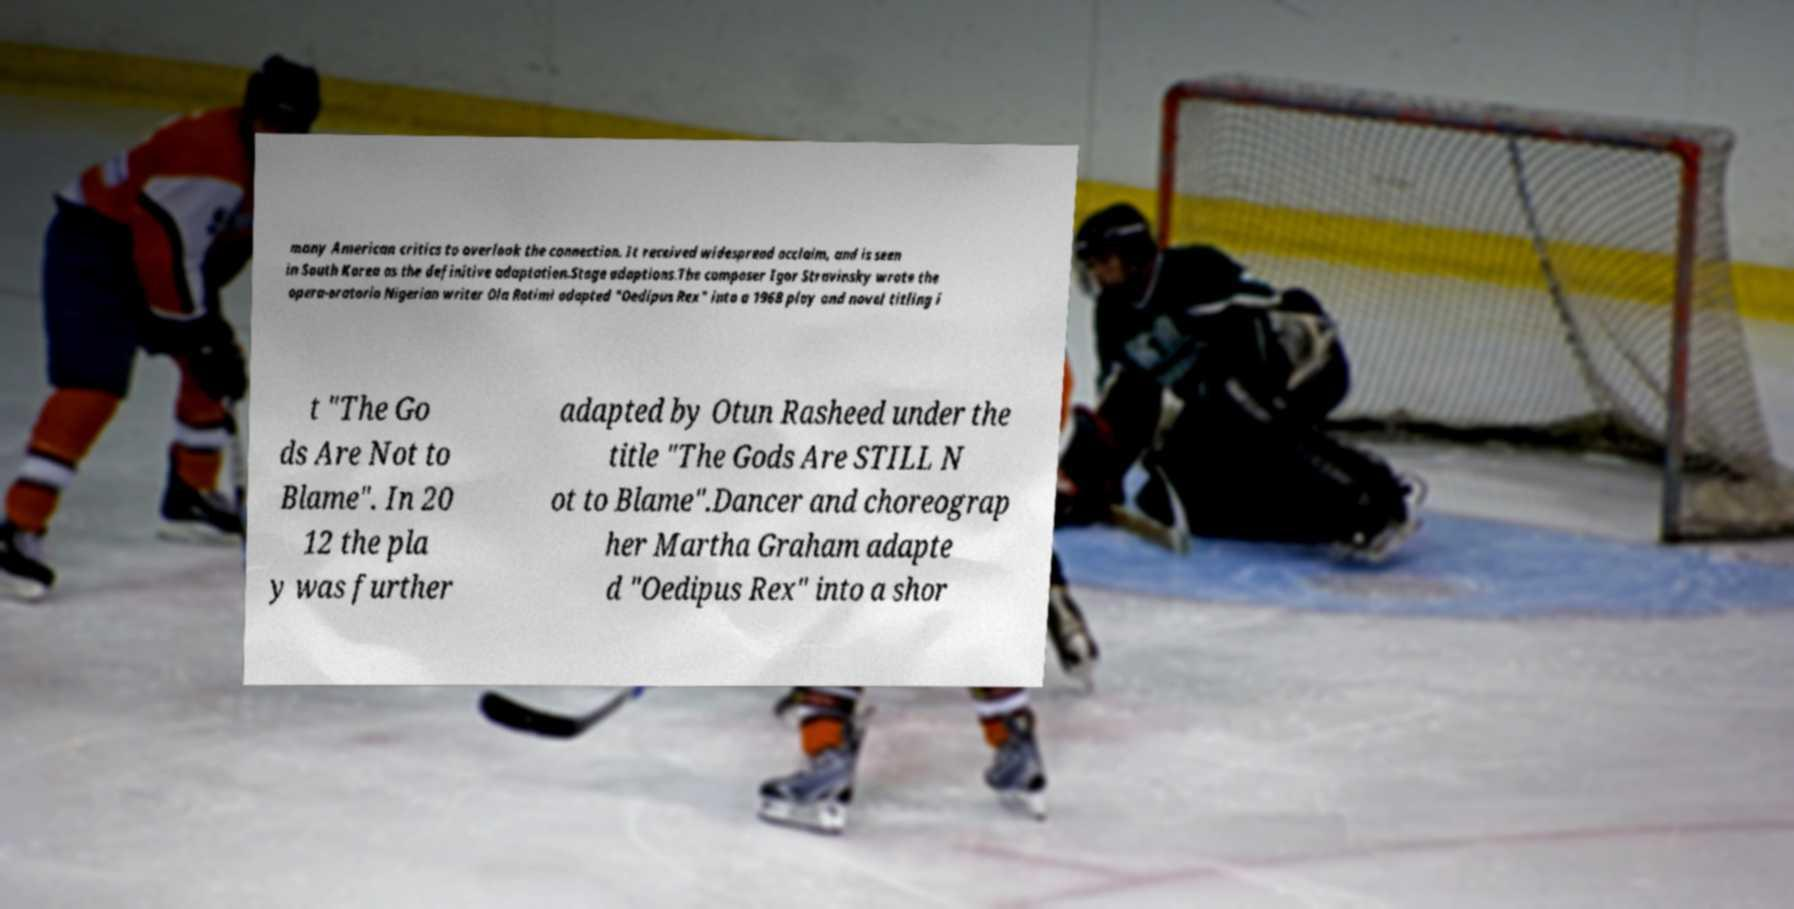There's text embedded in this image that I need extracted. Can you transcribe it verbatim? many American critics to overlook the connection. It received widespread acclaim, and is seen in South Korea as the definitive adaptation.Stage adaptions.The composer Igor Stravinsky wrote the opera-oratorio Nigerian writer Ola Rotimi adapted "Oedipus Rex" into a 1968 play and novel titling i t "The Go ds Are Not to Blame". In 20 12 the pla y was further adapted by Otun Rasheed under the title "The Gods Are STILL N ot to Blame".Dancer and choreograp her Martha Graham adapte d "Oedipus Rex" into a shor 